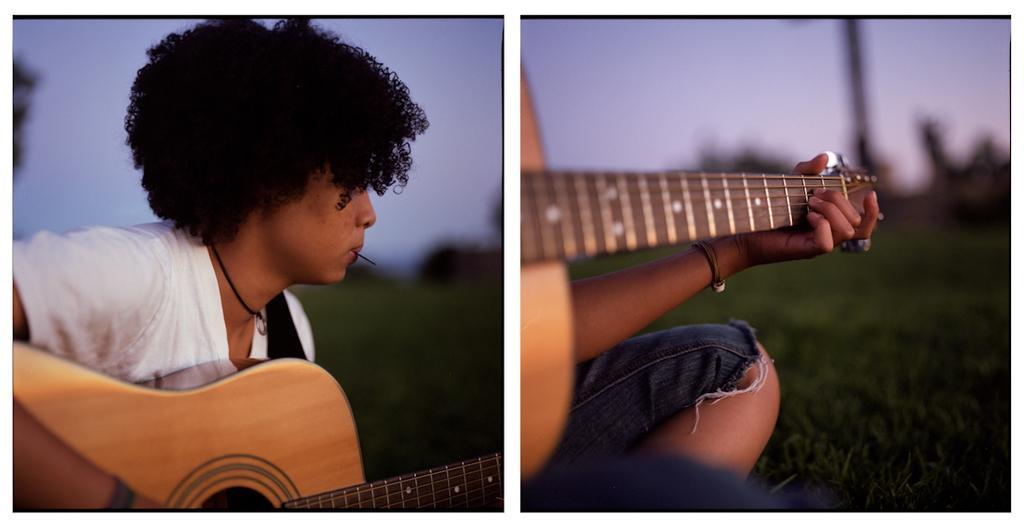Describe this image in one or two sentences. This is a college picture, in the picture a man in white t shirt was playing a guitar and in his mouth there is something and in the other picture the man is wearing a bracelet to his left hand. Behind the man is in blue and sky. 